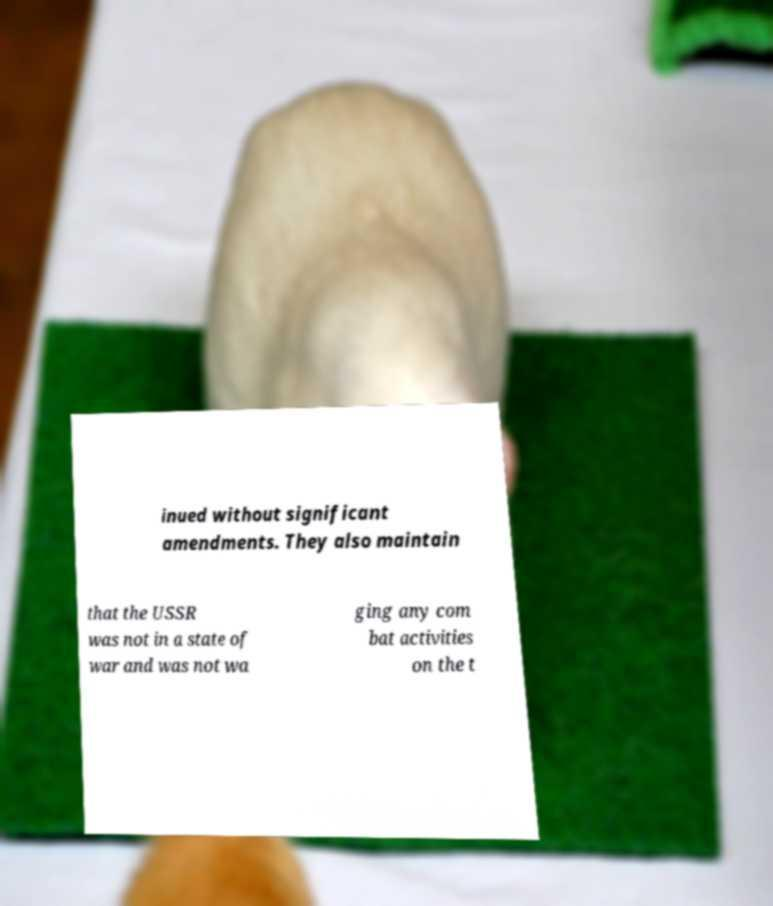What messages or text are displayed in this image? I need them in a readable, typed format. inued without significant amendments. They also maintain that the USSR was not in a state of war and was not wa ging any com bat activities on the t 